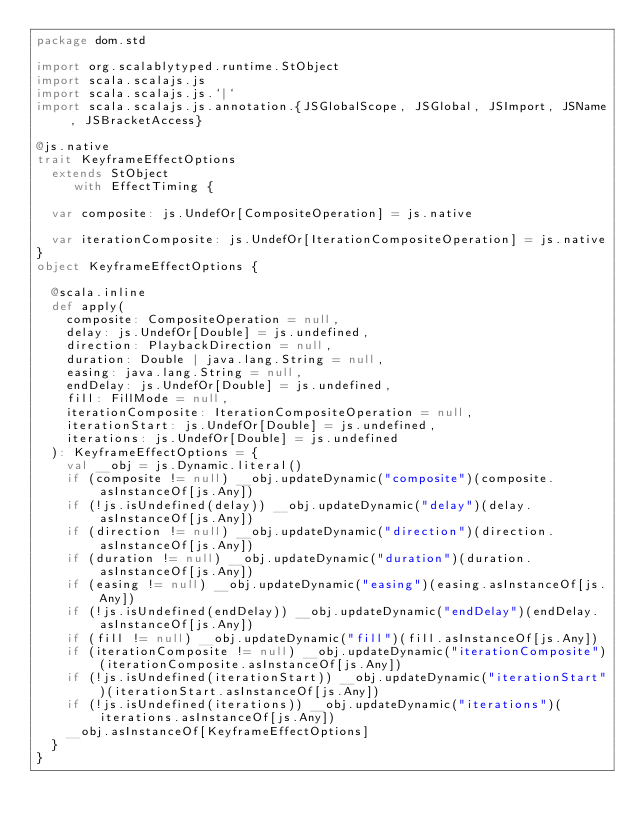Convert code to text. <code><loc_0><loc_0><loc_500><loc_500><_Scala_>package dom.std

import org.scalablytyped.runtime.StObject
import scala.scalajs.js
import scala.scalajs.js.`|`
import scala.scalajs.js.annotation.{JSGlobalScope, JSGlobal, JSImport, JSName, JSBracketAccess}

@js.native
trait KeyframeEffectOptions
  extends StObject
     with EffectTiming {
  
  var composite: js.UndefOr[CompositeOperation] = js.native
  
  var iterationComposite: js.UndefOr[IterationCompositeOperation] = js.native
}
object KeyframeEffectOptions {
  
  @scala.inline
  def apply(
    composite: CompositeOperation = null,
    delay: js.UndefOr[Double] = js.undefined,
    direction: PlaybackDirection = null,
    duration: Double | java.lang.String = null,
    easing: java.lang.String = null,
    endDelay: js.UndefOr[Double] = js.undefined,
    fill: FillMode = null,
    iterationComposite: IterationCompositeOperation = null,
    iterationStart: js.UndefOr[Double] = js.undefined,
    iterations: js.UndefOr[Double] = js.undefined
  ): KeyframeEffectOptions = {
    val __obj = js.Dynamic.literal()
    if (composite != null) __obj.updateDynamic("composite")(composite.asInstanceOf[js.Any])
    if (!js.isUndefined(delay)) __obj.updateDynamic("delay")(delay.asInstanceOf[js.Any])
    if (direction != null) __obj.updateDynamic("direction")(direction.asInstanceOf[js.Any])
    if (duration != null) __obj.updateDynamic("duration")(duration.asInstanceOf[js.Any])
    if (easing != null) __obj.updateDynamic("easing")(easing.asInstanceOf[js.Any])
    if (!js.isUndefined(endDelay)) __obj.updateDynamic("endDelay")(endDelay.asInstanceOf[js.Any])
    if (fill != null) __obj.updateDynamic("fill")(fill.asInstanceOf[js.Any])
    if (iterationComposite != null) __obj.updateDynamic("iterationComposite")(iterationComposite.asInstanceOf[js.Any])
    if (!js.isUndefined(iterationStart)) __obj.updateDynamic("iterationStart")(iterationStart.asInstanceOf[js.Any])
    if (!js.isUndefined(iterations)) __obj.updateDynamic("iterations")(iterations.asInstanceOf[js.Any])
    __obj.asInstanceOf[KeyframeEffectOptions]
  }
}
</code> 